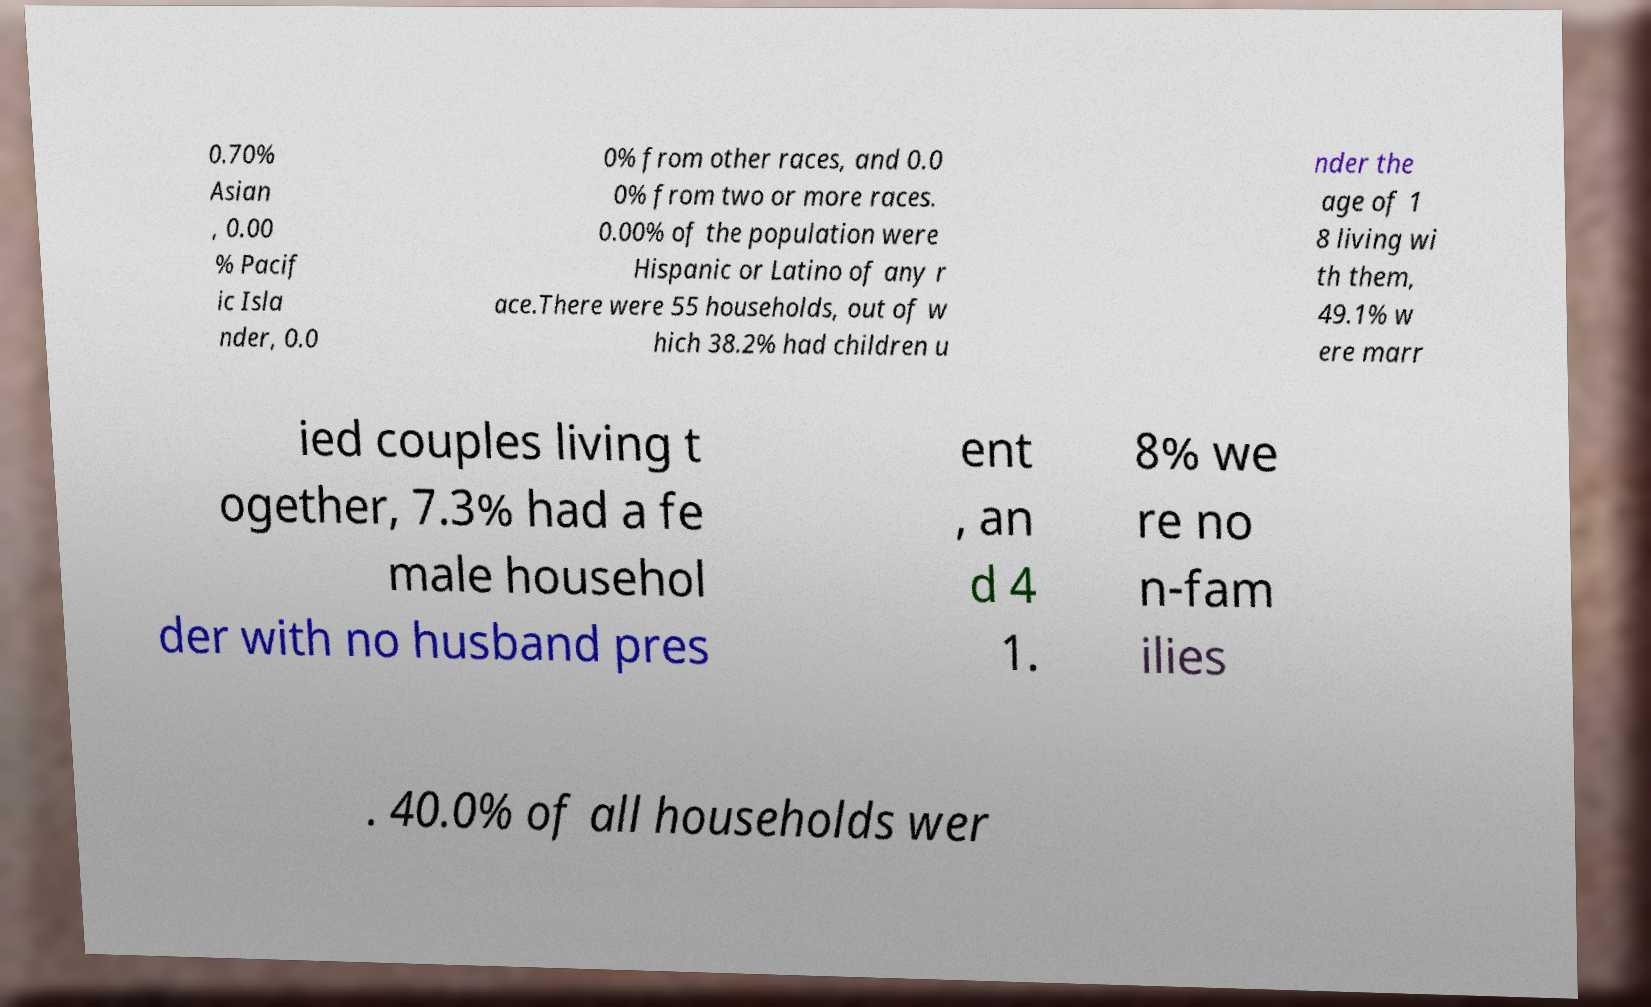Please identify and transcribe the text found in this image. 0.70% Asian , 0.00 % Pacif ic Isla nder, 0.0 0% from other races, and 0.0 0% from two or more races. 0.00% of the population were Hispanic or Latino of any r ace.There were 55 households, out of w hich 38.2% had children u nder the age of 1 8 living wi th them, 49.1% w ere marr ied couples living t ogether, 7.3% had a fe male househol der with no husband pres ent , an d 4 1. 8% we re no n-fam ilies . 40.0% of all households wer 